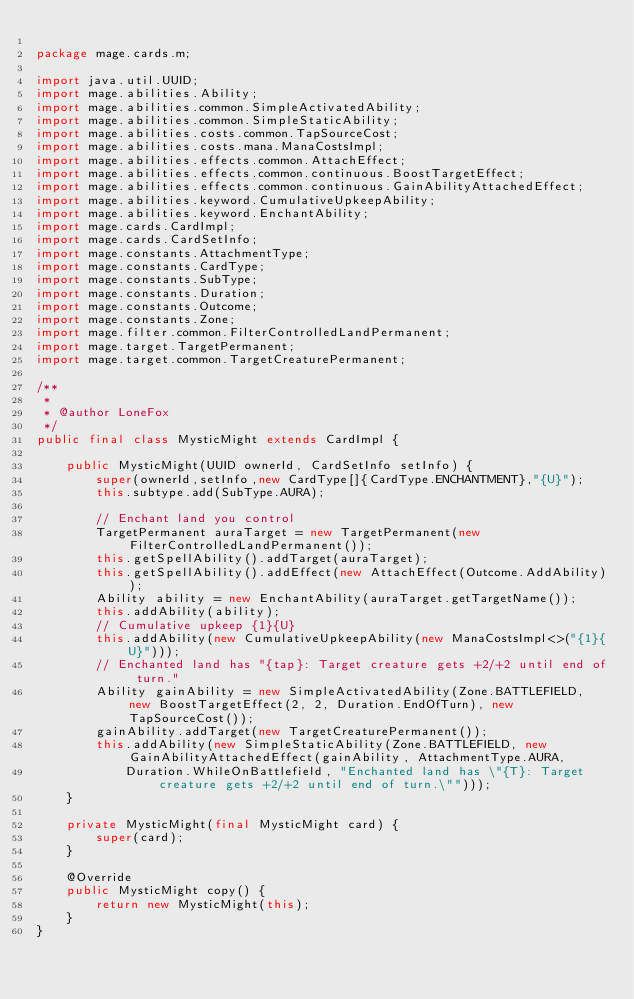<code> <loc_0><loc_0><loc_500><loc_500><_Java_>
package mage.cards.m;

import java.util.UUID;
import mage.abilities.Ability;
import mage.abilities.common.SimpleActivatedAbility;
import mage.abilities.common.SimpleStaticAbility;
import mage.abilities.costs.common.TapSourceCost;
import mage.abilities.costs.mana.ManaCostsImpl;
import mage.abilities.effects.common.AttachEffect;
import mage.abilities.effects.common.continuous.BoostTargetEffect;
import mage.abilities.effects.common.continuous.GainAbilityAttachedEffect;
import mage.abilities.keyword.CumulativeUpkeepAbility;
import mage.abilities.keyword.EnchantAbility;
import mage.cards.CardImpl;
import mage.cards.CardSetInfo;
import mage.constants.AttachmentType;
import mage.constants.CardType;
import mage.constants.SubType;
import mage.constants.Duration;
import mage.constants.Outcome;
import mage.constants.Zone;
import mage.filter.common.FilterControlledLandPermanent;
import mage.target.TargetPermanent;
import mage.target.common.TargetCreaturePermanent;

/**
 *
 * @author LoneFox
 */
public final class MysticMight extends CardImpl {

    public MysticMight(UUID ownerId, CardSetInfo setInfo) {
        super(ownerId,setInfo,new CardType[]{CardType.ENCHANTMENT},"{U}");
        this.subtype.add(SubType.AURA);

        // Enchant land you control
        TargetPermanent auraTarget = new TargetPermanent(new FilterControlledLandPermanent());
        this.getSpellAbility().addTarget(auraTarget);
        this.getSpellAbility().addEffect(new AttachEffect(Outcome.AddAbility));
        Ability ability = new EnchantAbility(auraTarget.getTargetName());
        this.addAbility(ability);
        // Cumulative upkeep {1}{U}
        this.addAbility(new CumulativeUpkeepAbility(new ManaCostsImpl<>("{1}{U}")));
        // Enchanted land has "{tap}: Target creature gets +2/+2 until end of turn."
        Ability gainAbility = new SimpleActivatedAbility(Zone.BATTLEFIELD, new BoostTargetEffect(2, 2, Duration.EndOfTurn), new TapSourceCost());
        gainAbility.addTarget(new TargetCreaturePermanent());
        this.addAbility(new SimpleStaticAbility(Zone.BATTLEFIELD, new GainAbilityAttachedEffect(gainAbility, AttachmentType.AURA,
            Duration.WhileOnBattlefield, "Enchanted land has \"{T}: Target creature gets +2/+2 until end of turn.\"")));
    }

    private MysticMight(final MysticMight card) {
        super(card);
    }

    @Override
    public MysticMight copy() {
        return new MysticMight(this);
    }
}
</code> 